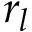Convert formula to latex. <formula><loc_0><loc_0><loc_500><loc_500>r _ { l }</formula> 